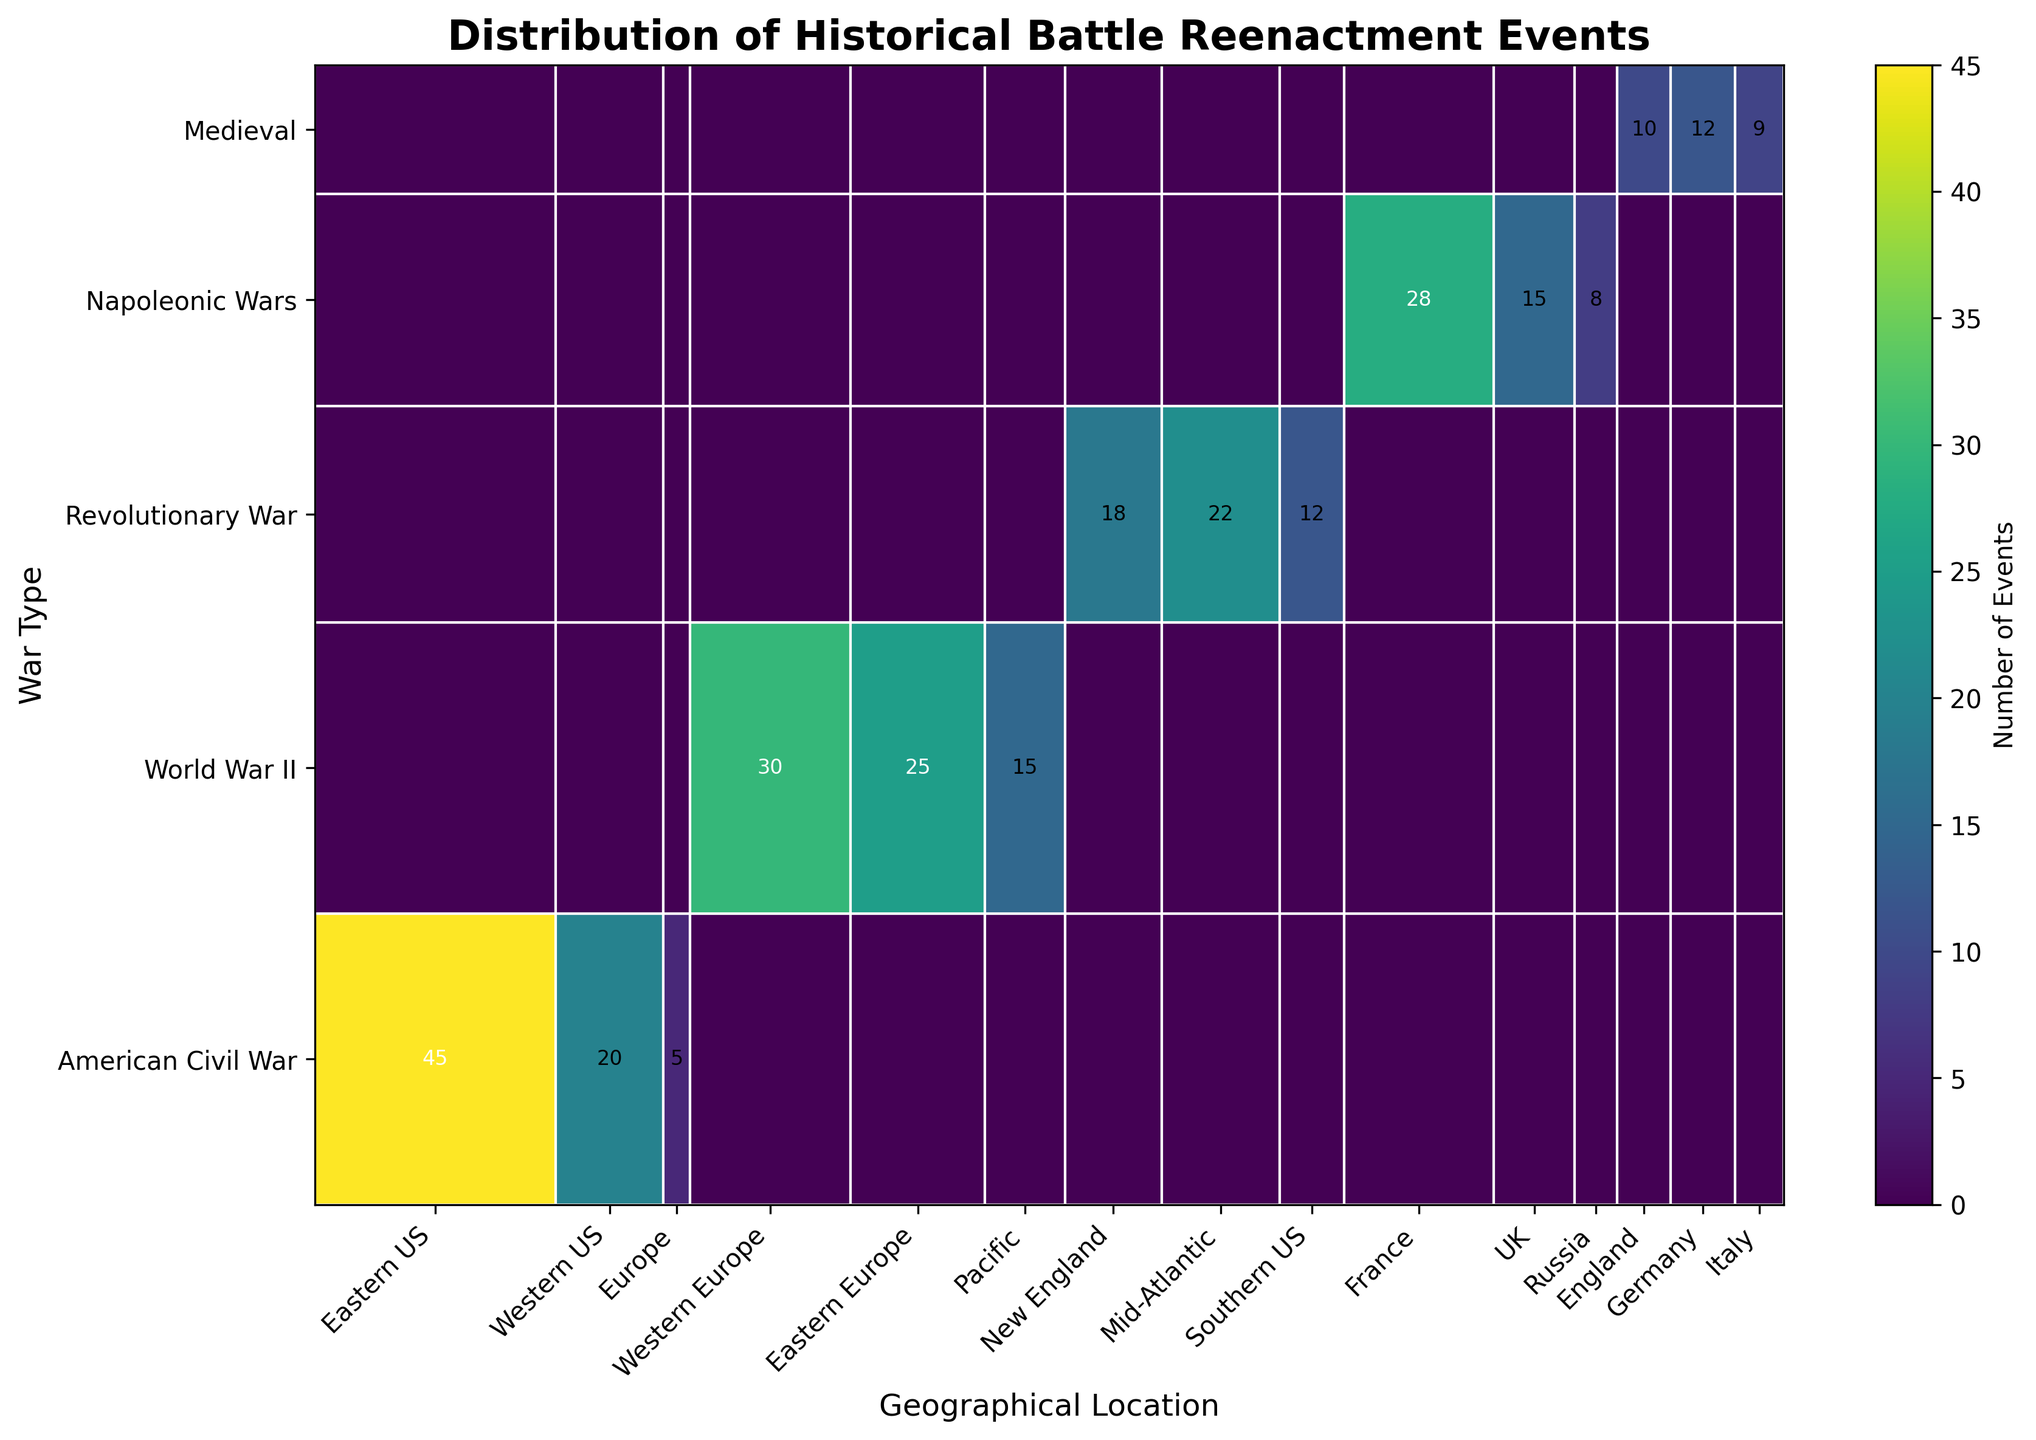What's the title of the figure? The title is often found at the top of the figure and typically describes what the figure is about.
Answer: Distribution of Historical Battle Reenactment Events How many geographical locations are represented in the figure? The number of geographical locations can be determined by counting the tick labels along the x-axis.
Answer: 11 Which war has the highest number of reenactment events in total? By looking at the y-axis categories and summing the number of events for each war, we see that the American Civil War has the highest total.
Answer: American Civil War Which location has the fewest number of reenactment events for World War II? By examining the areas corresponding to World War II and comparing the size of the sections, it's clear the Pacific region has fewer events.
Answer: Pacific What is the total number of medieval reenactment events depicted in the figure? By summing the number of events in the sections labeled Medieval across all locations, the total is 10 (England) + 12 (Germany) + 9 (Italy).
Answer: 31 Are there more reenactment events for the American Civil War in the Eastern US or the Western US? By comparing the areas of the sections for the American Civil War in the Eastern US and the Western US, the Eastern US has more events.
Answer: Eastern US Which location has the most diverse representation of war types based on the figure? The most diverse location would have a presence of many different war type sections. By examining this, the Eastern US and Western Europe show representation from more than one war.
Answer: Eastern US Which war type has a notable number of events in both Europe and the United States? By identifying the war types with sections in both Europe and the US, the American Civil War and World War II are notable.
Answer: World War II Which war type has the smallest overall number of reenactment events? By examining the sizes of the sections for each war type, the Napoleonic Wars has the smallest sum across all locations.
Answer: Napoleonic Wars 